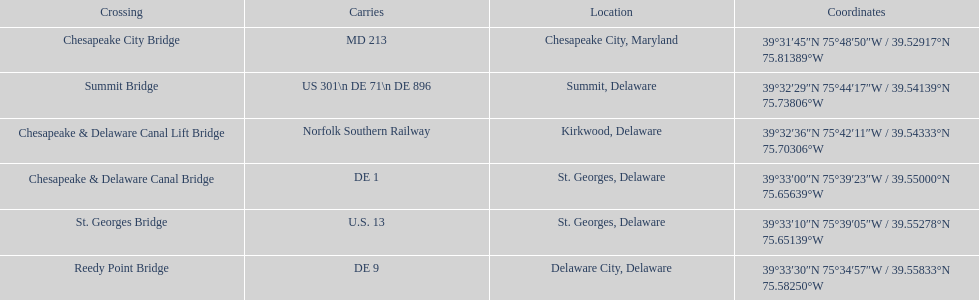Help me parse the entirety of this table. {'header': ['Crossing', 'Carries', 'Location', 'Coordinates'], 'rows': [['Chesapeake City Bridge', 'MD 213', 'Chesapeake City, Maryland', '39°31′45″N 75°48′50″W\ufeff / \ufeff39.52917°N 75.81389°W'], ['Summit Bridge', 'US 301\\n DE 71\\n DE 896', 'Summit, Delaware', '39°32′29″N 75°44′17″W\ufeff / \ufeff39.54139°N 75.73806°W'], ['Chesapeake & Delaware Canal Lift Bridge', 'Norfolk Southern Railway', 'Kirkwood, Delaware', '39°32′36″N 75°42′11″W\ufeff / \ufeff39.54333°N 75.70306°W'], ['Chesapeake & Delaware Canal Bridge', 'DE 1', 'St.\xa0Georges, Delaware', '39°33′00″N 75°39′23″W\ufeff / \ufeff39.55000°N 75.65639°W'], ['St.\xa0Georges Bridge', 'U.S.\xa013', 'St.\xa0Georges, Delaware', '39°33′10″N 75°39′05″W\ufeff / \ufeff39.55278°N 75.65139°W'], ['Reedy Point Bridge', 'DE\xa09', 'Delaware City, Delaware', '39°33′30″N 75°34′57″W\ufeff / \ufeff39.55833°N 75.58250°W']]} How many crossings are in maryland? 1. 